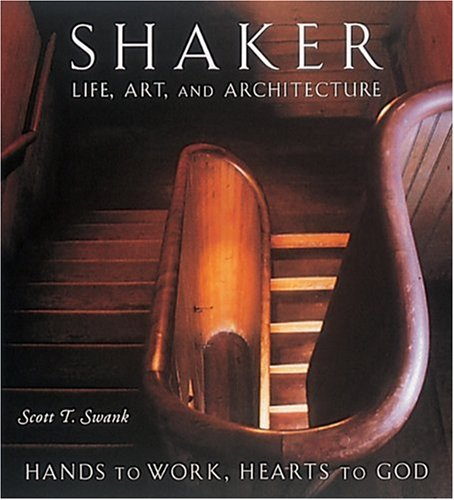Who is the author of this book? The author of the book shown is Scott T. Swank, a noted historian and writer who specializes in Shaker crafts and their historical impact. 